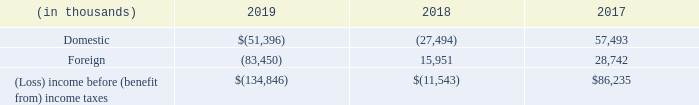16. INCOME TAXES
The components of (loss) income before (benefit from) income taxes are:
What are the respective loss before income tax benefits in 2018 and 2019?
Answer scale should be: thousand. 11,543, 134,846. What are the respective domestic and foreign income before income taxes in 2017?
Answer scale should be: thousand. 57,493, 28,742. What are the respective domestic and foreign losses before income tax benefits in 2019?
Answer scale should be: thousand. 51,396, 83,450. What is the average loss from domestic and foreign sources in 2019?
Answer scale should be: thousand. (51,396 + 83,450)/2
Answer: 67423. What is the average loss made by the company in 2018 and 2019?
Answer scale should be: thousand. (11,543 + 134,846)/2 
Answer: 73194.5. What is the percentage change in income from foreign sources between 2017 and 2018?
Answer scale should be: percent. (15,951 - 28,742)/28,742 
Answer: -44.5. 